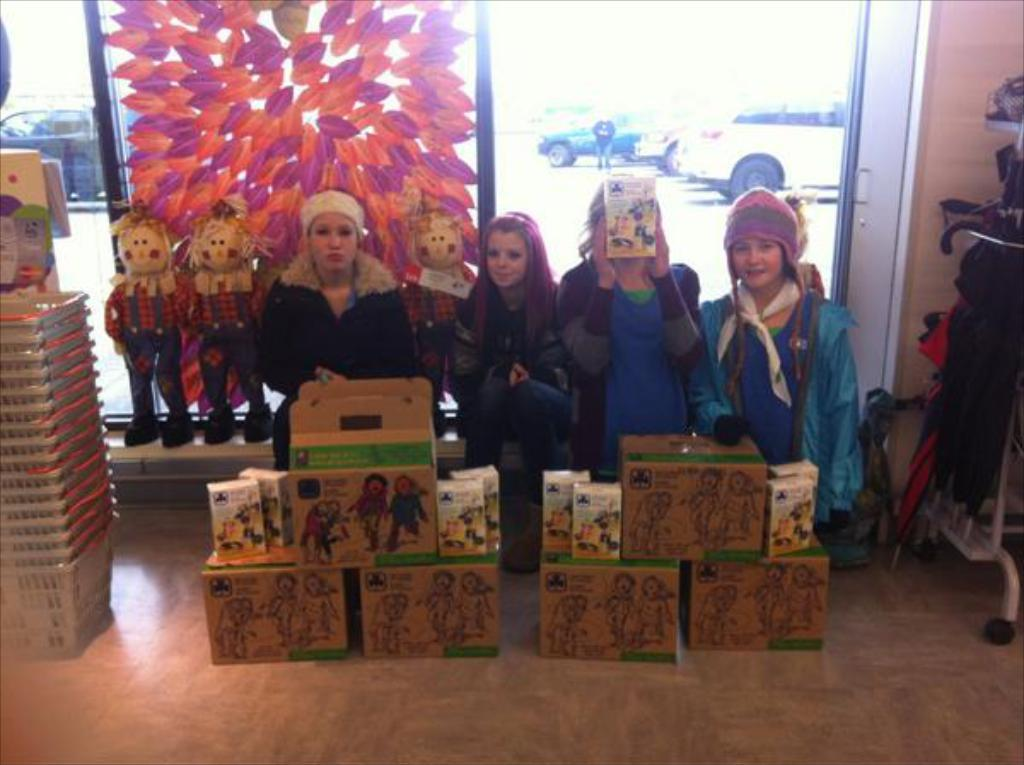What objects are on the floor in the image? There are baskets and boxes on the floor in the image. Who or what can be seen in the image? There are people visible in the image. What type of items are present for children to play with? There are toys in the image. Can you describe any unspecified objects in the image? There are some unspecified objects in the image. What can be seen in the background of the image? There are vehicles visible in the background of the image. What type of coil is being used to paint the space shuttle in the image? There is no space shuttle, coil, or paint present in the image. 